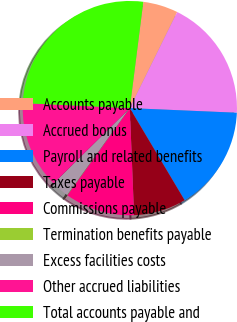Convert chart. <chart><loc_0><loc_0><loc_500><loc_500><pie_chart><fcel>Accounts payable<fcel>Accrued bonus<fcel>Payroll and related benefits<fcel>Taxes payable<fcel>Commissions payable<fcel>Termination benefits payable<fcel>Excess facilities costs<fcel>Other accrued liabilities<fcel>Total accounts payable and<nl><fcel>5.28%<fcel>18.39%<fcel>15.77%<fcel>7.91%<fcel>10.53%<fcel>0.04%<fcel>2.66%<fcel>13.15%<fcel>26.26%<nl></chart> 